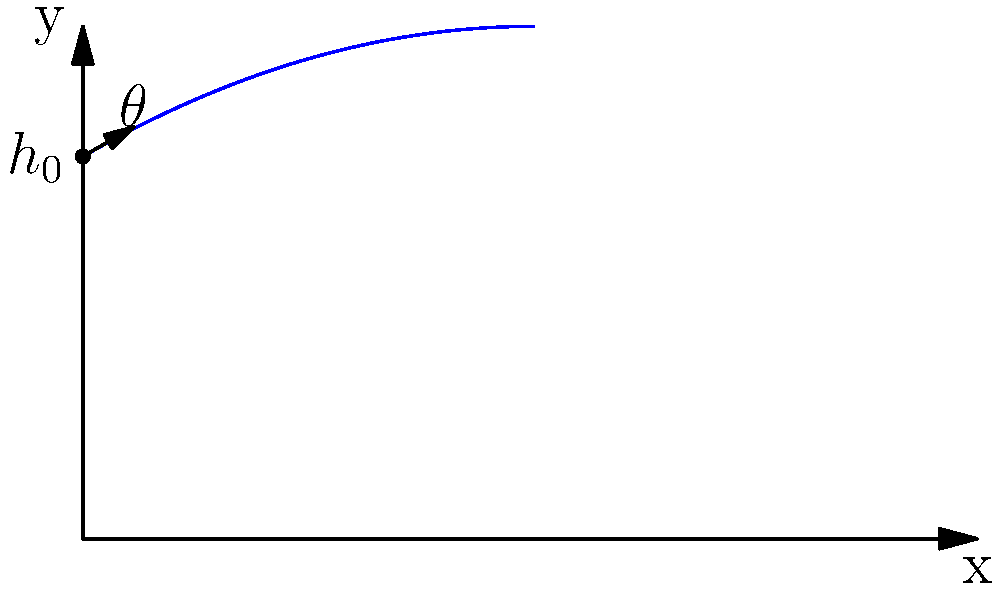In a political rally, a campaign balloon is launched from a platform 15 meters high at an angle of 30° to the horizontal with an initial velocity of 20 m/s. Assuming no air resistance, what is the maximum height reached by the balloon? How does this trajectory metaphorically represent the rise and fall of political careers? To find the maximum height reached by the balloon, we need to follow these steps:

1. Identify the given information:
   - Initial height (h₀) = 15 m
   - Initial velocity (v₀) = 20 m/s
   - Launch angle (θ) = 30°
   - Acceleration due to gravity (g) = 9.8 m/s²

2. Calculate the vertical component of the initial velocity:
   $v_{0y} = v_0 \sin(\theta) = 20 \sin(30°) = 10$ m/s

3. Use the equation for maximum height reached by a projectile launched upward:
   $h_{max} = h_0 + \frac{v_{0y}^2}{2g}$

4. Substitute the values into the equation:
   $h_{max} = 15 + \frac{10^2}{2(9.8)} = 15 + 5.1 = 20.1$ m

The trajectory metaphorically represents political careers as follows:
- The initial height (platform) represents the starting position or advantage in a political career.
- The launch angle and velocity represent the initial strategy and momentum of a political campaign.
- The parabolic path shows the rise and fall of political influence over time.
- The maximum height represents the peak of a politician's career or the height of their influence.
- The eventual return to the ground level symbolizes the end of a political career or term in office.

This analogy can be used to discuss how political careers often have a trajectory with a rise, peak, and eventual decline, much like the path of the projectile.
Answer: 20.1 meters 